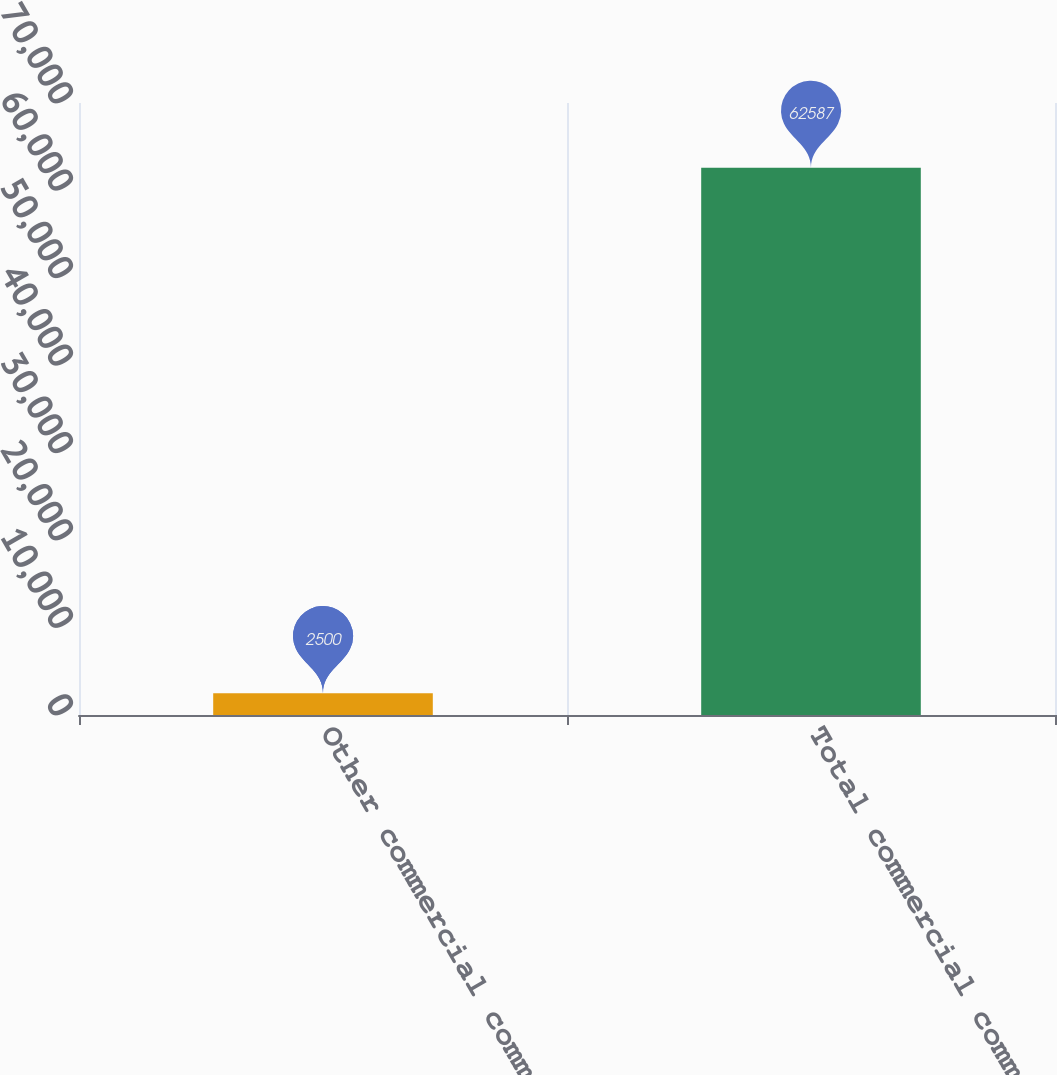Convert chart. <chart><loc_0><loc_0><loc_500><loc_500><bar_chart><fcel>Other commercial commitments<fcel>Total commercial commitments<nl><fcel>2500<fcel>62587<nl></chart> 